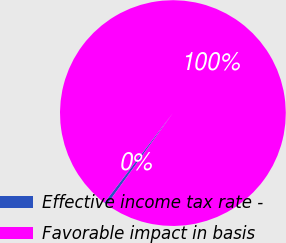Convert chart. <chart><loc_0><loc_0><loc_500><loc_500><pie_chart><fcel>Effective income tax rate -<fcel>Favorable impact in basis<nl><fcel>0.45%<fcel>99.55%<nl></chart> 